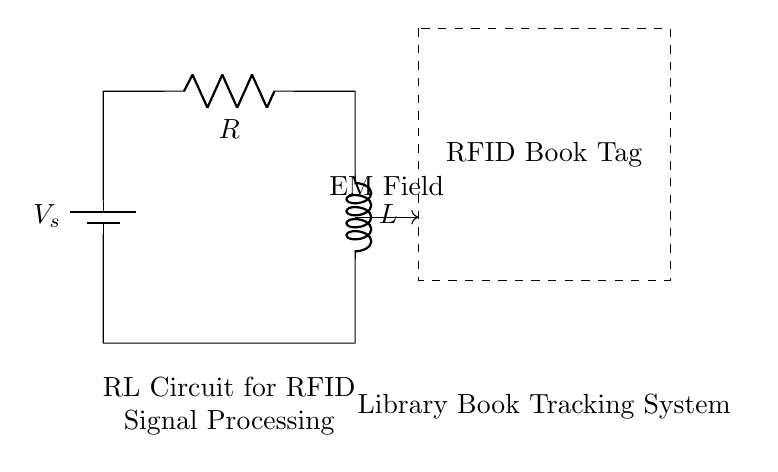What is the source voltage in this circuit? The source voltage is indicated by the symbol V_s at the top left of the diagram. It represents the voltage supplied to the circuit components.
Answer: V_s What components are present in the circuit? The circuit diagram shows a battery, a resistor labeled R, and an inductor labeled L, which are the components necessary for the RL circuit functionality.
Answer: Battery, Resistor, Inductor What is the role of the inductor in this circuit? The inductor in the circuit is used to store energy in a magnetic field when current passes through it; this plays a critical role in filtering and signal processing for the RFID system.
Answer: Energy storage What does the dashed rectangle represent? The dashed rectangle in the circuit diagram encloses an RFID book tag, which is a crucial component of the library's book tracking system, indicating the system's implementation.
Answer: RFID Book Tag What type of circuit is represented by this diagram? The circuit is classified as an RL circuit, which specifically includes a resistor and an inductor working together to manage current and voltage changes effectively, especially useful in signal processing applications.
Answer: RL Circuit How does the inductor affect the current flow? The inductor resists changes in current due to its property of inductance, which means that it can delay current increase and decrease, impacting how the circuit reacts to the RFID signal.
Answer: Delays current change What function does the resistor serve in this circuit? The resistor limits the flow of current in the circuit, which helps in controlling signal strength and ensuring that the RFID system operates within safe parameters to prevent damage to components.
Answer: Current limitation 